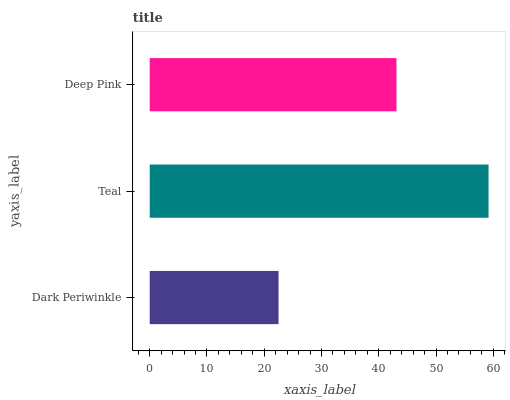Is Dark Periwinkle the minimum?
Answer yes or no. Yes. Is Teal the maximum?
Answer yes or no. Yes. Is Deep Pink the minimum?
Answer yes or no. No. Is Deep Pink the maximum?
Answer yes or no. No. Is Teal greater than Deep Pink?
Answer yes or no. Yes. Is Deep Pink less than Teal?
Answer yes or no. Yes. Is Deep Pink greater than Teal?
Answer yes or no. No. Is Teal less than Deep Pink?
Answer yes or no. No. Is Deep Pink the high median?
Answer yes or no. Yes. Is Deep Pink the low median?
Answer yes or no. Yes. Is Dark Periwinkle the high median?
Answer yes or no. No. Is Teal the low median?
Answer yes or no. No. 